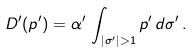<formula> <loc_0><loc_0><loc_500><loc_500>D ^ { \prime } ( p ^ { \prime } ) = \alpha ^ { \prime } \, \int _ { | \sigma ^ { \prime } | > 1 } p ^ { \prime } \, d \sigma ^ { \prime } \, .</formula> 